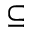<formula> <loc_0><loc_0><loc_500><loc_500>\subseteq</formula> 